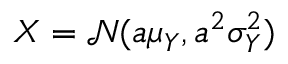<formula> <loc_0><loc_0><loc_500><loc_500>X = \mathcal { N } ( a \mu _ { Y } , a ^ { 2 } \sigma _ { Y } ^ { 2 } )</formula> 